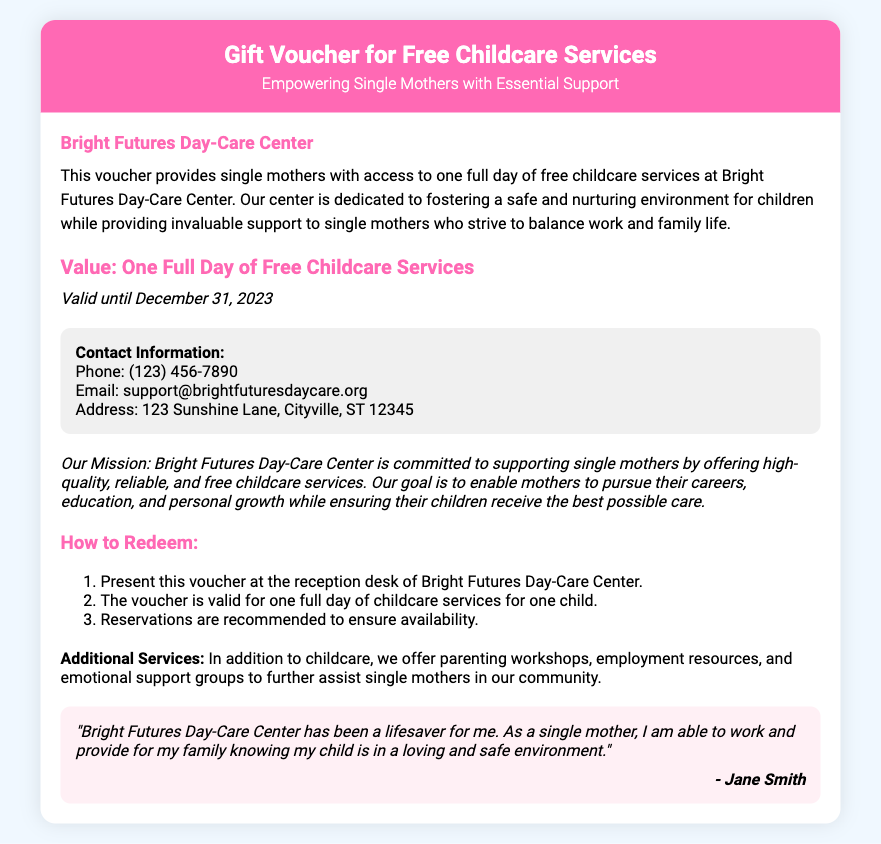What is the name of the day-care center? The issuer of the voucher is listed as the day-care center, which is Bright Futures Day-Care Center.
Answer: Bright Futures Day-Care Center What is the value of the voucher? The voucher provides access to one full day of free childcare services, as mentioned in the document.
Answer: One Full Day of Free Childcare Services What is the validity date of the voucher? The document states that the voucher is valid until December 31, 2023.
Answer: December 31, 2023 What is the mission of the day-care center? The mission is described in a specific section that highlights their commitment to supporting single mothers.
Answer: Supporting single mothers How many steps are there to redeem the voucher? The document outlines the redemption process in an ordered list, which contains three steps.
Answer: Three What additional services does the day-care center offer? The document mentions several services, including parenting workshops and employment resources alongside childcare.
Answer: Parenting workshops, employment resources Who is the author of the testimonial? The name of the person providing the testimonial is mentioned at the end of the quote.
Answer: Jane Smith What phone number can be used for contact? The contact information includes the phone number provided for inquiries related to the day-care center.
Answer: (123) 456-7890 